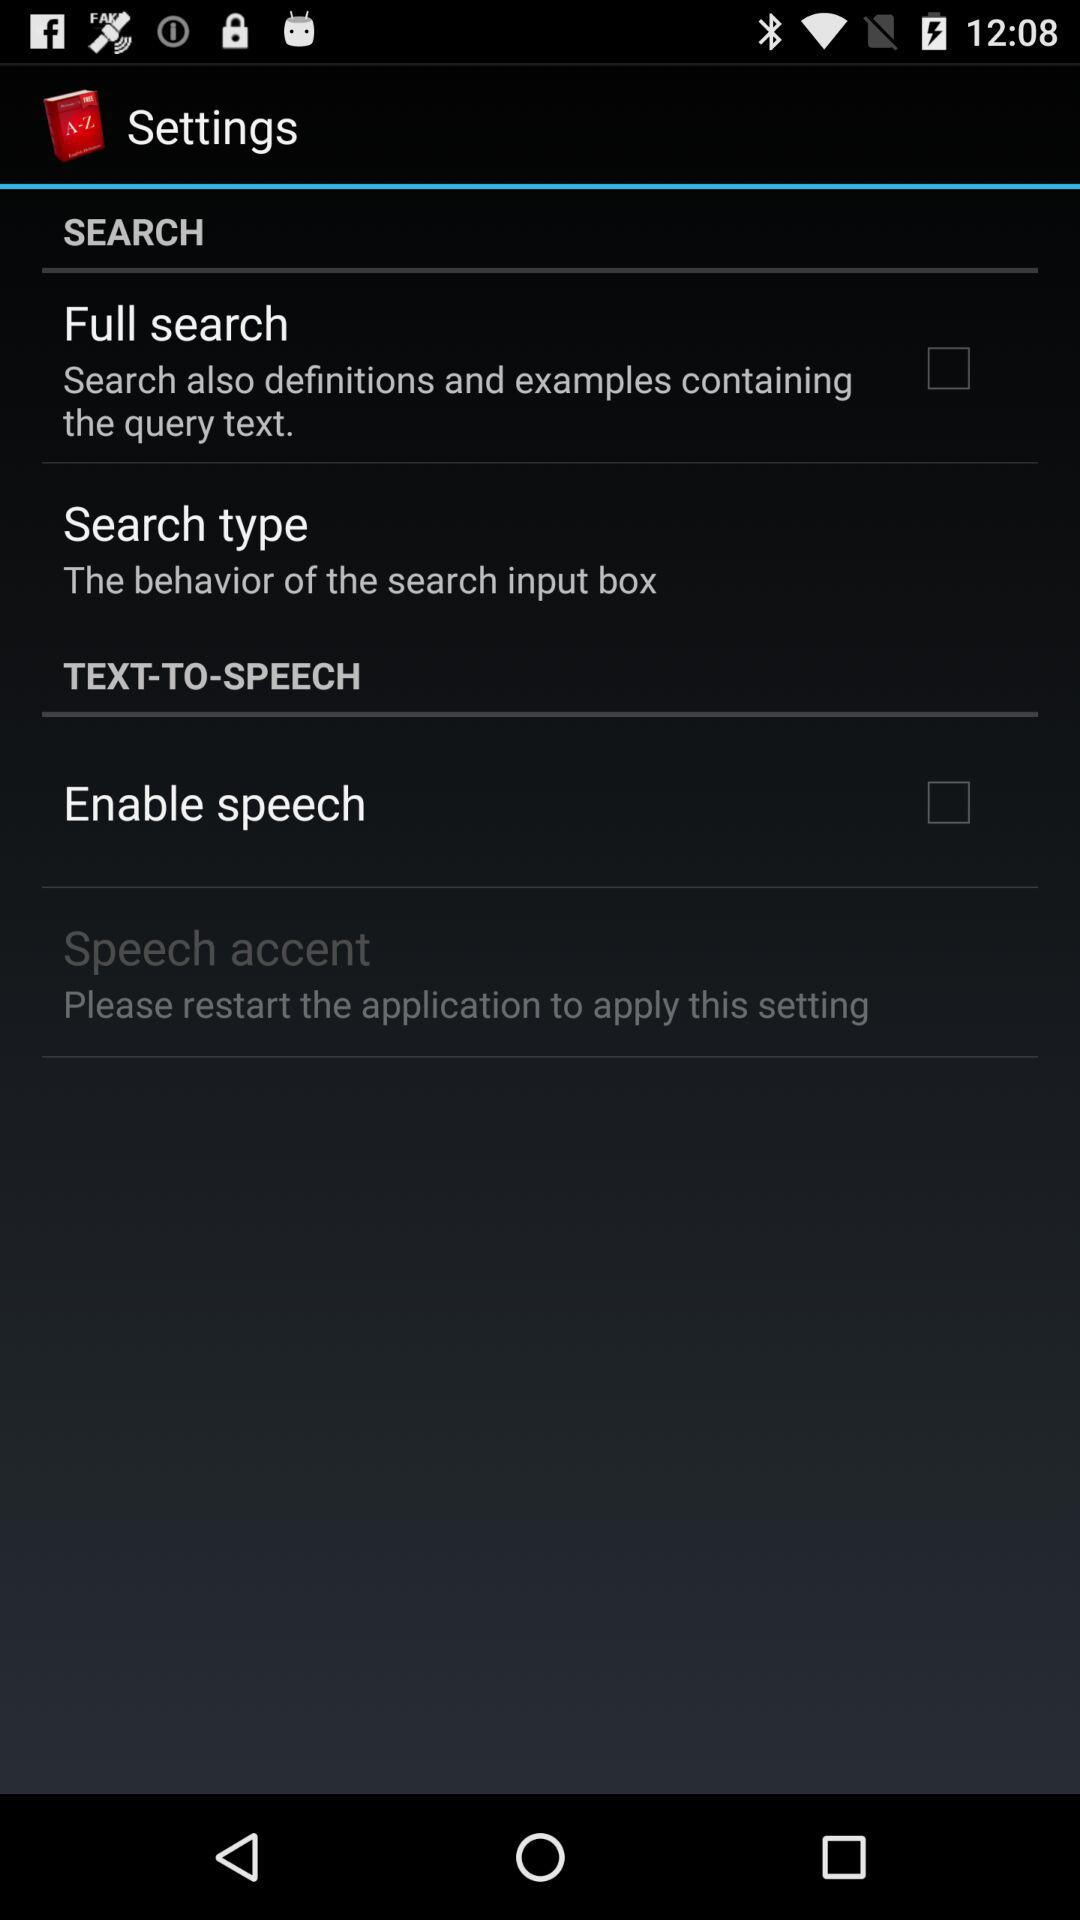How many items have the text "Search" in their label?
Answer the question using a single word or phrase. 2 